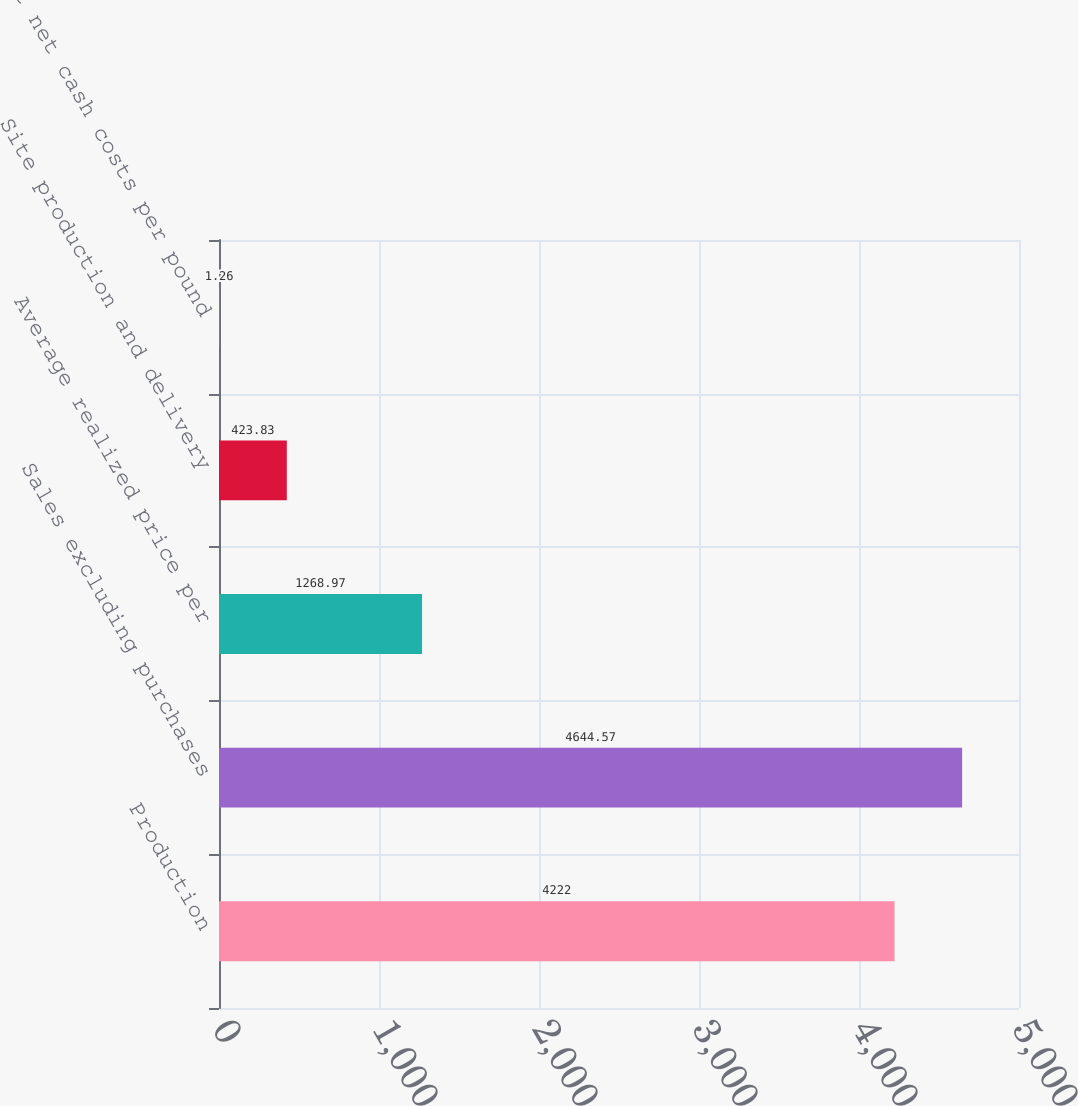Convert chart. <chart><loc_0><loc_0><loc_500><loc_500><bar_chart><fcel>Production<fcel>Sales excluding purchases<fcel>Average realized price per<fcel>Site production and delivery<fcel>Unit net cash costs per pound<nl><fcel>4222<fcel>4644.57<fcel>1268.97<fcel>423.83<fcel>1.26<nl></chart> 